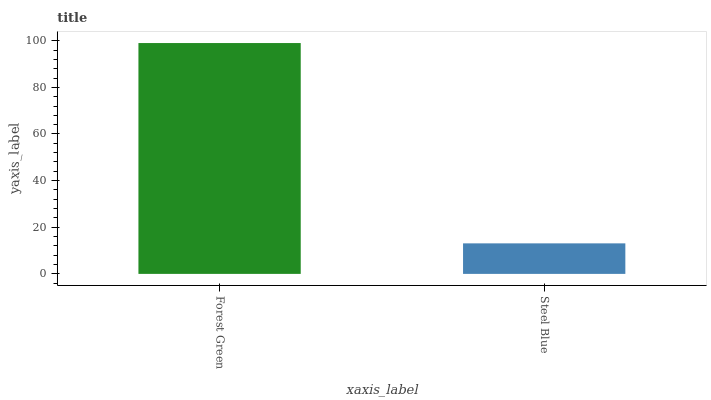Is Steel Blue the minimum?
Answer yes or no. Yes. Is Forest Green the maximum?
Answer yes or no. Yes. Is Steel Blue the maximum?
Answer yes or no. No. Is Forest Green greater than Steel Blue?
Answer yes or no. Yes. Is Steel Blue less than Forest Green?
Answer yes or no. Yes. Is Steel Blue greater than Forest Green?
Answer yes or no. No. Is Forest Green less than Steel Blue?
Answer yes or no. No. Is Forest Green the high median?
Answer yes or no. Yes. Is Steel Blue the low median?
Answer yes or no. Yes. Is Steel Blue the high median?
Answer yes or no. No. Is Forest Green the low median?
Answer yes or no. No. 